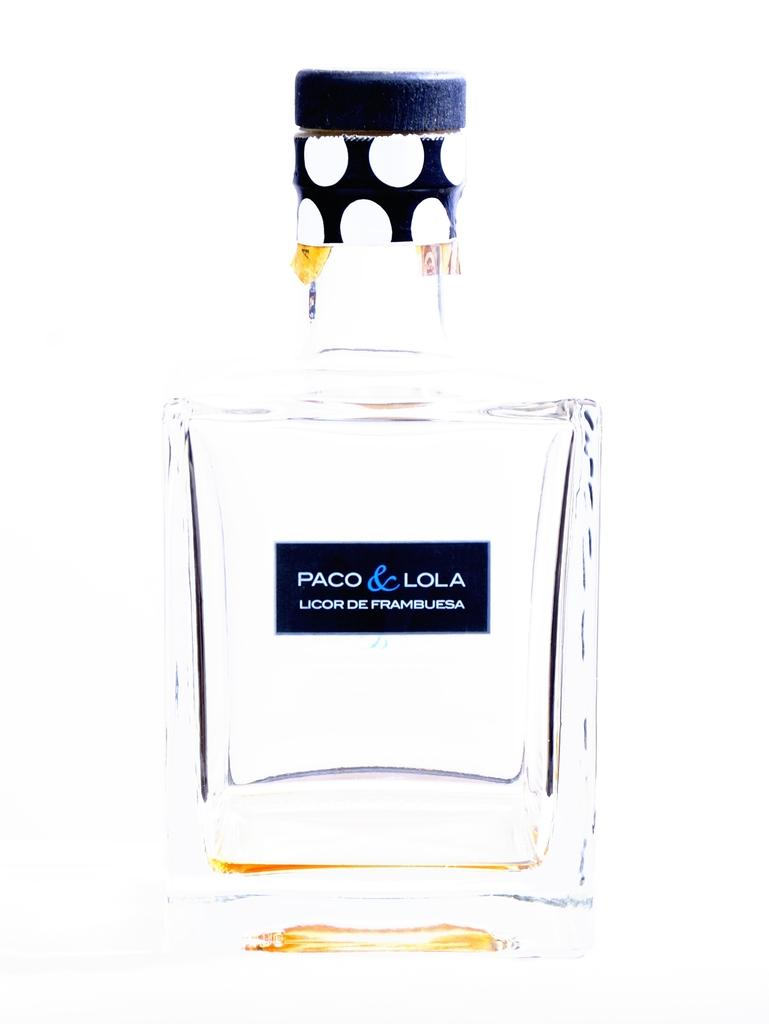What object is the main subject of the image? There is a perfume bottle in the image. What feature of the perfume bottle can be observed? The perfume bottle has a lid. What information is provided on the perfume bottle? The perfume bottle has a label with the name of the perfume. Can you tell me how the pet is driving the car in the image? There is no pet or car present in the image. What thought is the perfume bottle having in the image? Perfume bottles do not have thoughts, as they are inanimate objects. 